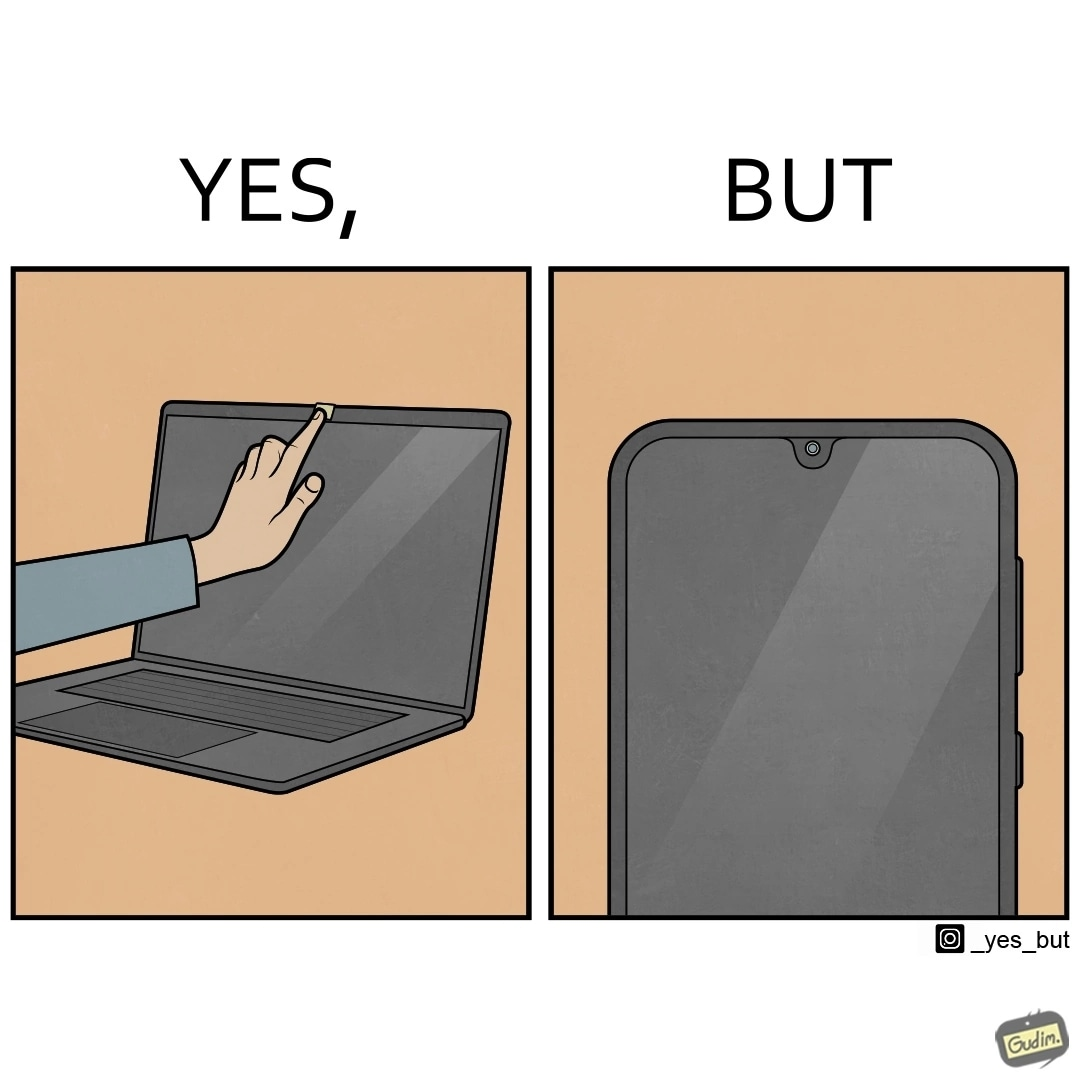Does this image contain satire or humor? Yes, this image is satirical. 